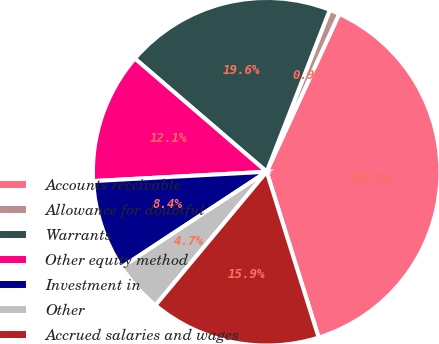Convert chart. <chart><loc_0><loc_0><loc_500><loc_500><pie_chart><fcel>Accounts receivable<fcel>Allowance for doubtful<fcel>Warrants<fcel>Other equity method<fcel>Investment in<fcel>Other<fcel>Accrued salaries and wages<nl><fcel>38.31%<fcel>0.94%<fcel>19.62%<fcel>12.15%<fcel>8.41%<fcel>4.68%<fcel>15.89%<nl></chart> 